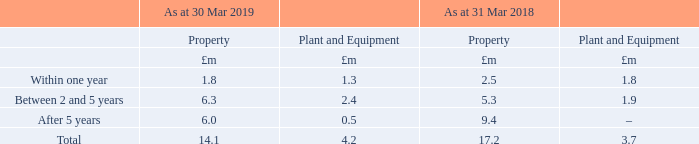24. Operating lease commitments
The Group has lease agreements in respect of property, plant and equipment, for which future minimum payments extend over a number of years.
Leases primarily relate to the Group’s properties, which principally comprise offices and factories. Lease payments are typically subject to market review every five years to reflect market rentals, but because of the uncertainty over the amount of any future changes, such changes have not been reflected in the table below. Within our leasing arrangements there are no significant contingent rental, renewal, purchase or escalation clauses.
The future aggregate minimum lease payments under non-cancellable operating leases for continuing operations are as follows:
The Group has made provision for the aggregate minimum lease payments under non-cancellable operating leases. The Group sub-lets various properties under non-cancellable lease arrangements. Sub-lease receipts of £0.2m (2017/18: £0.2m) were recognised in the statement of profit or loss during the period. The total future minimum sub-lease payments at the period end is £0.2m (2017/18: £0.2m).
What was the property payment within between 2 and 5 years in 2019?
Answer scale should be: million. 6.3. What was the total property payment in 2019?
Answer scale should be: million. 14.1. What was the property payment within one year in 2019?
Answer scale should be: million. 1.8. What was the change in the property payment within one year from 2018 to 2019?
Answer scale should be: million. 1.8 - 2.5
Answer: -0.7. What is the average plant and equipment payment due between 2 and 5 years in 2018 and 2019?
Answer scale should be: million. (2.4 + 1.9) / 2
Answer: 2.15. What is the change in the total property payment due from 2018 to 2019?
Answer scale should be: million. 14.1 - 17.2
Answer: -3.1. 